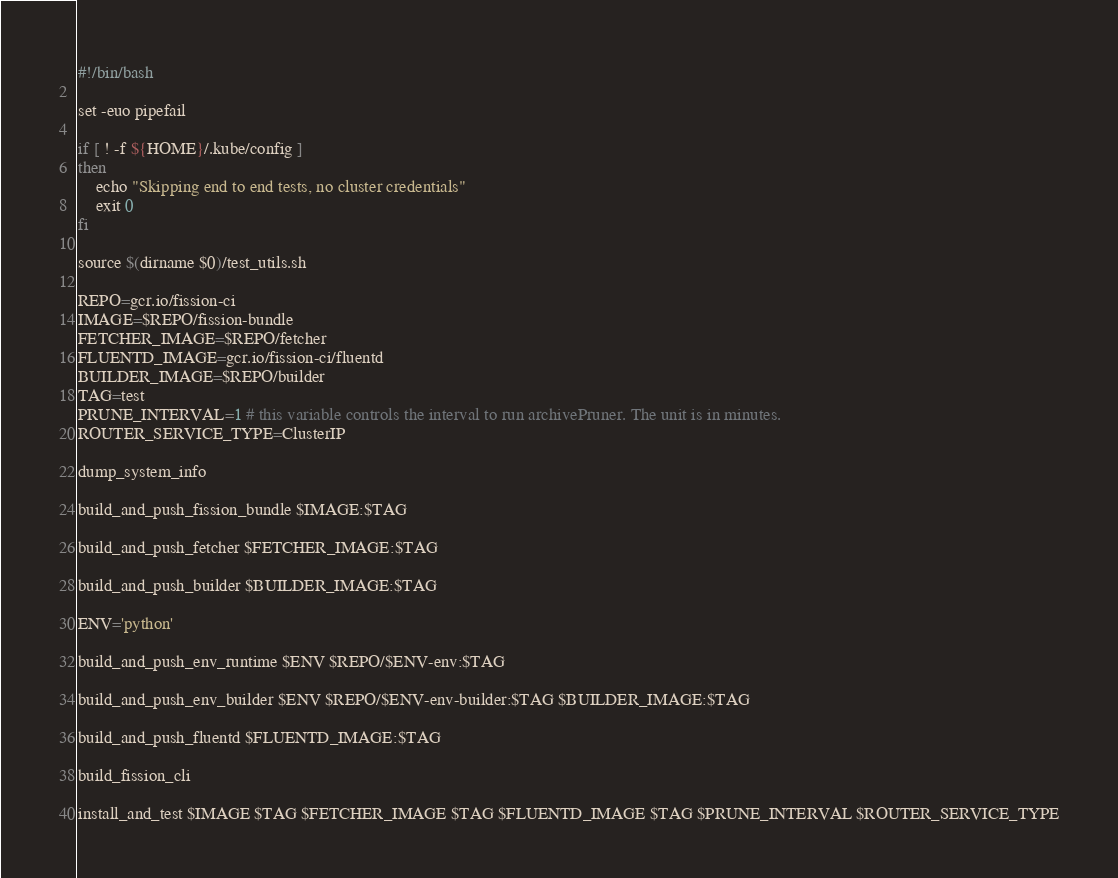Convert code to text. <code><loc_0><loc_0><loc_500><loc_500><_Bash_>#!/bin/bash

set -euo pipefail

if [ ! -f ${HOME}/.kube/config ]
then
    echo "Skipping end to end tests, no cluster credentials"
    exit 0
fi

source $(dirname $0)/test_utils.sh

REPO=gcr.io/fission-ci
IMAGE=$REPO/fission-bundle
FETCHER_IMAGE=$REPO/fetcher
FLUENTD_IMAGE=gcr.io/fission-ci/fluentd
BUILDER_IMAGE=$REPO/builder
TAG=test
PRUNE_INTERVAL=1 # this variable controls the interval to run archivePruner. The unit is in minutes.
ROUTER_SERVICE_TYPE=ClusterIP

dump_system_info

build_and_push_fission_bundle $IMAGE:$TAG

build_and_push_fetcher $FETCHER_IMAGE:$TAG

build_and_push_builder $BUILDER_IMAGE:$TAG

ENV='python'

build_and_push_env_runtime $ENV $REPO/$ENV-env:$TAG

build_and_push_env_builder $ENV $REPO/$ENV-env-builder:$TAG $BUILDER_IMAGE:$TAG

build_and_push_fluentd $FLUENTD_IMAGE:$TAG

build_fission_cli

install_and_test $IMAGE $TAG $FETCHER_IMAGE $TAG $FLUENTD_IMAGE $TAG $PRUNE_INTERVAL $ROUTER_SERVICE_TYPE
</code> 